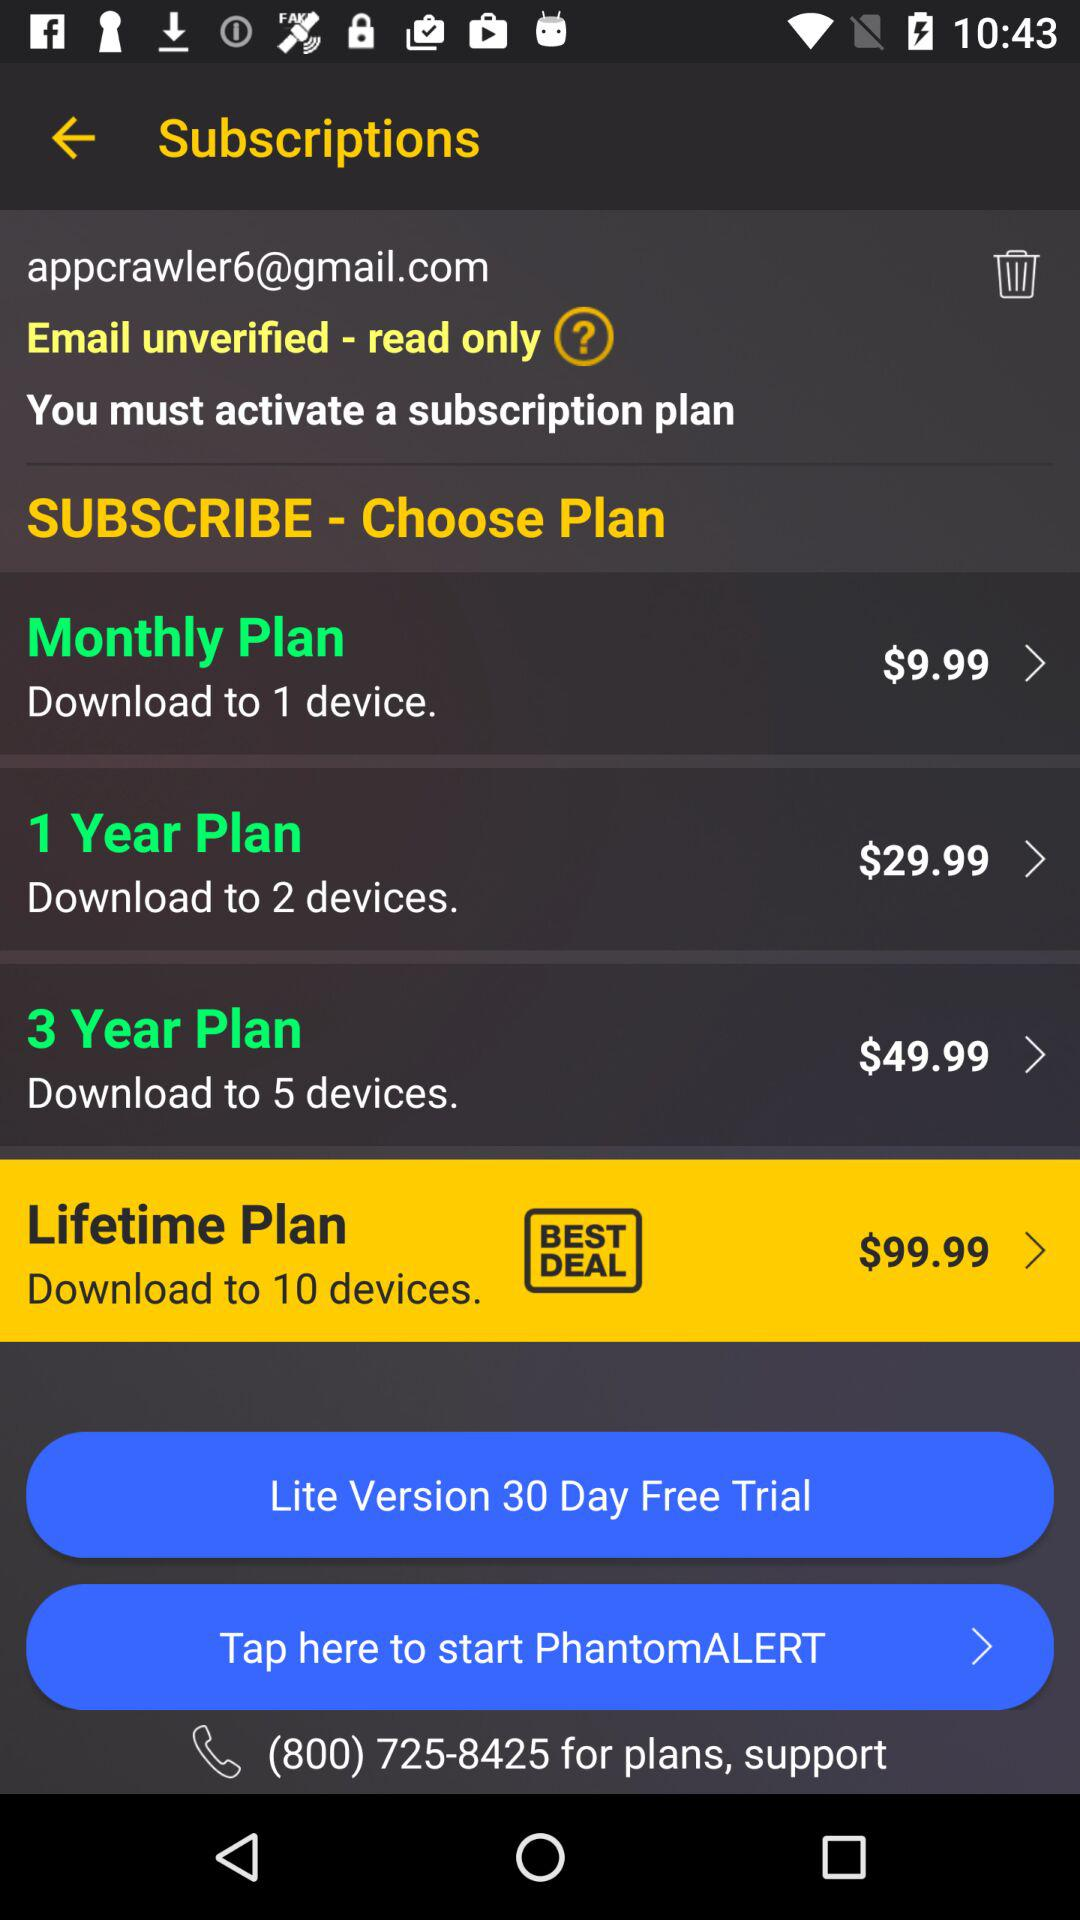What is the email address? The email address is appcrawler6@gmail.com. 